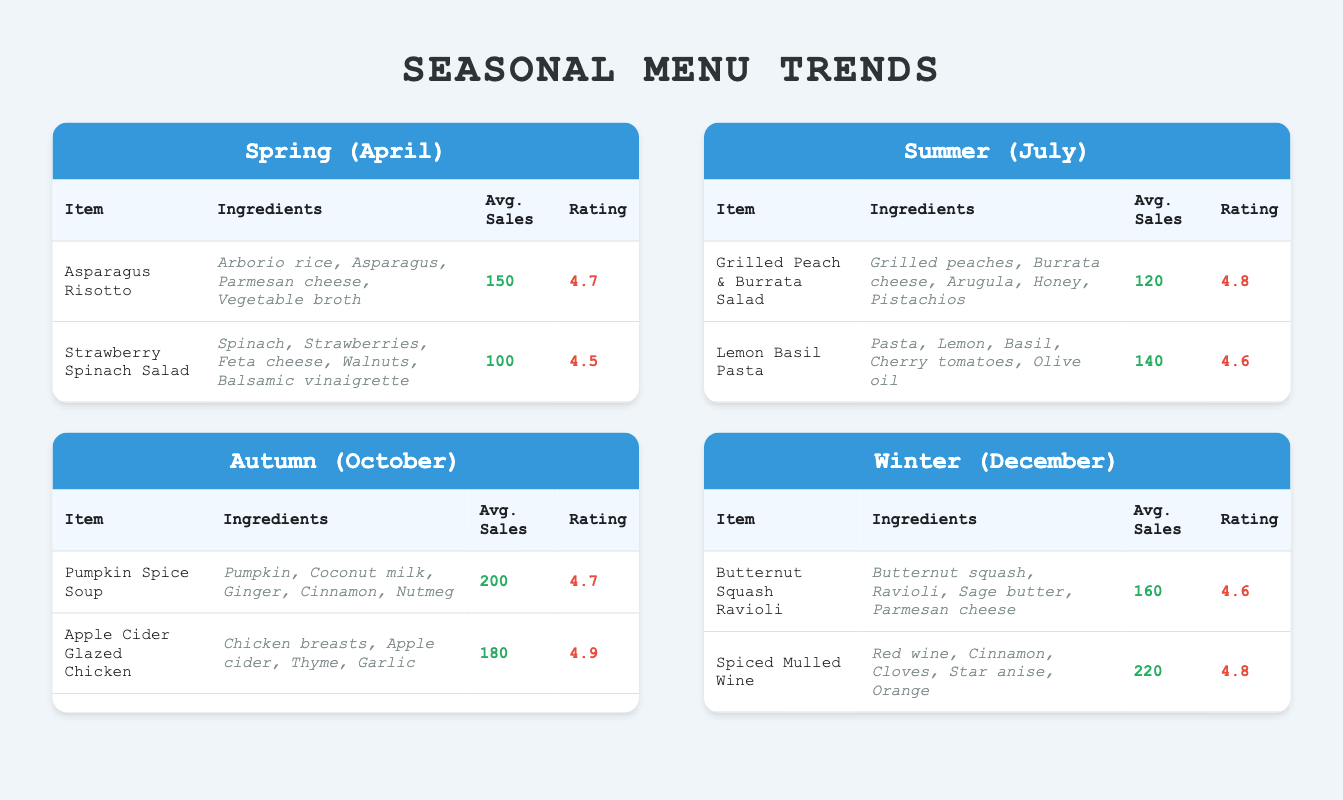What are the average sales for the Pumpkin Spice Soup in Autumn? The table indicates the average sales for "Pumpkin Spice Soup" under the Autumn section, which is directly listed as 200.
Answer: 200 Which menu item has the highest customer rating in Winter? In the Winter section, there are two items: "Butternut Squash Ravioli" with a rating of 4.6 and "Spiced Mulled Wine" with a rating of 4.8. Comparing these, "Spiced Mulled Wine" has the highest rating.
Answer: Spiced Mulled Wine How many total average sales do the popular menu items have in Summer? The average sales for the Summer items are "Grilled Peach & Burrata Salad" with 120 and "Lemon Basil Pasta" with 140. Adding these gives 120 + 140 = 260.
Answer: 260 Is the average sales for "Apple Cider Glazed Chicken" higher than that of "Asparagus Risotto"? The average sales for "Apple Cider Glazed Chicken" in Autumn is 180, and for "Asparagus Risotto" in Spring, it is 150. Since 180 is greater than 150, the statement is true.
Answer: Yes What is the difference in average sales between the highest-selling item in Autumn and the lowest-selling item in Spring? The highest-selling item in Autumn is "Pumpkin Spice Soup" with 200 average sales, and the lowest-selling item in Spring is "Strawberry Spinach Salad" with 100 average sales. The difference is 200 - 100 = 100.
Answer: 100 Which season has the most popular menu item based on the highest average sales? Looking across the seasons, the highest average sales are for "Spiced Mulled Wine" at 220 during Winter, which is greater than the highest sales items of other seasons: 200 in Autumn, 150 in Spring, and 140 in Summer. So Winter has the most popular item.
Answer: Winter Are there any menu items with a customer rating of 4.5 or lower? Checking the customer ratings, the lowest listed rating is 4.5 for "Strawberry Spinach Salad." Since it meets the condition of being 4.5 or lower, the answer is yes.
Answer: Yes What is the average customer rating of all popular menu items in Spring? The customer ratings for Spring items are 4.7 for "Asparagus Risotto" and 4.5 for "Strawberry Spinach Salad." Therefore, the average rating is (4.7 + 4.5) / 2 = 4.6.
Answer: 4.6 